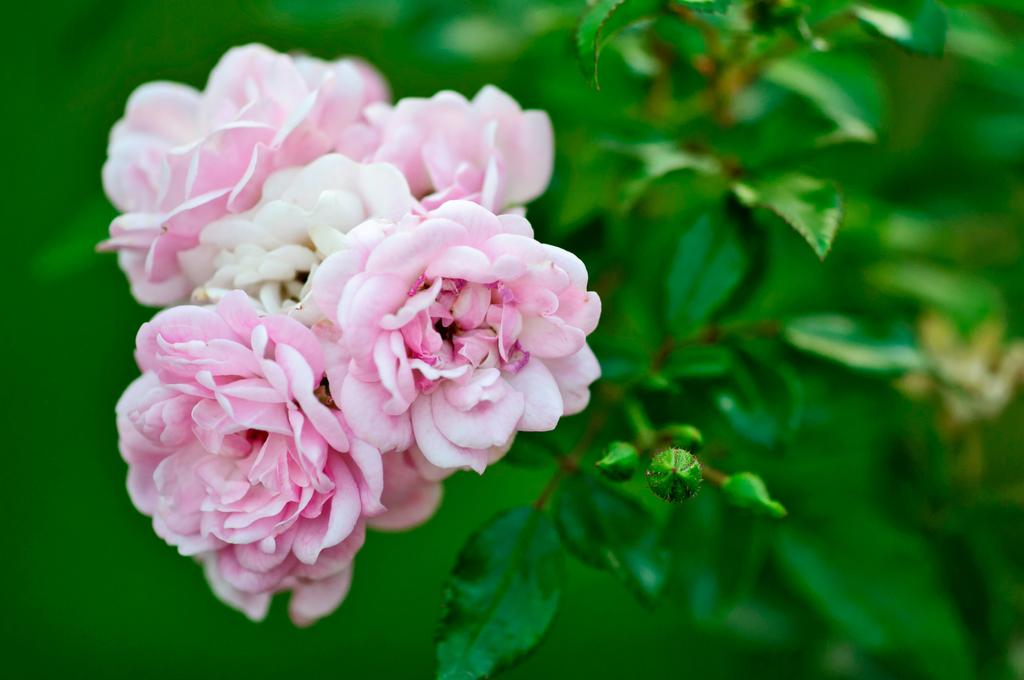What type of plants can be seen in the image? There are flowers in the image. Can you describe the stage of growth for the flowers? There are buds on the plant in the image, indicating that the flowers are not yet fully bloomed. What type of fish can be seen swimming in the image? There is no fish present in the image; it only features flowers and buds on a plant. 